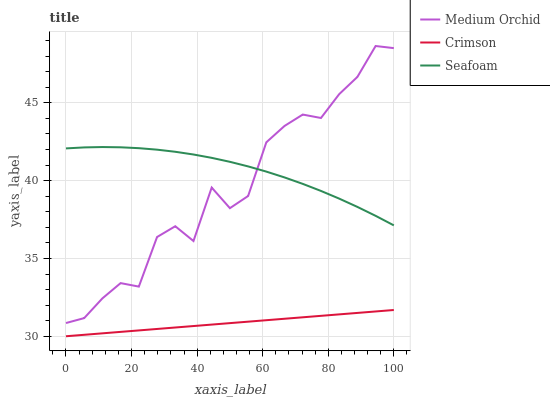Does Crimson have the minimum area under the curve?
Answer yes or no. Yes. Does Seafoam have the maximum area under the curve?
Answer yes or no. Yes. Does Medium Orchid have the minimum area under the curve?
Answer yes or no. No. Does Medium Orchid have the maximum area under the curve?
Answer yes or no. No. Is Crimson the smoothest?
Answer yes or no. Yes. Is Medium Orchid the roughest?
Answer yes or no. Yes. Is Seafoam the smoothest?
Answer yes or no. No. Is Seafoam the roughest?
Answer yes or no. No. Does Crimson have the lowest value?
Answer yes or no. Yes. Does Medium Orchid have the lowest value?
Answer yes or no. No. Does Medium Orchid have the highest value?
Answer yes or no. Yes. Does Seafoam have the highest value?
Answer yes or no. No. Is Crimson less than Seafoam?
Answer yes or no. Yes. Is Seafoam greater than Crimson?
Answer yes or no. Yes. Does Medium Orchid intersect Seafoam?
Answer yes or no. Yes. Is Medium Orchid less than Seafoam?
Answer yes or no. No. Is Medium Orchid greater than Seafoam?
Answer yes or no. No. Does Crimson intersect Seafoam?
Answer yes or no. No. 